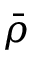<formula> <loc_0><loc_0><loc_500><loc_500>\bar { \rho }</formula> 